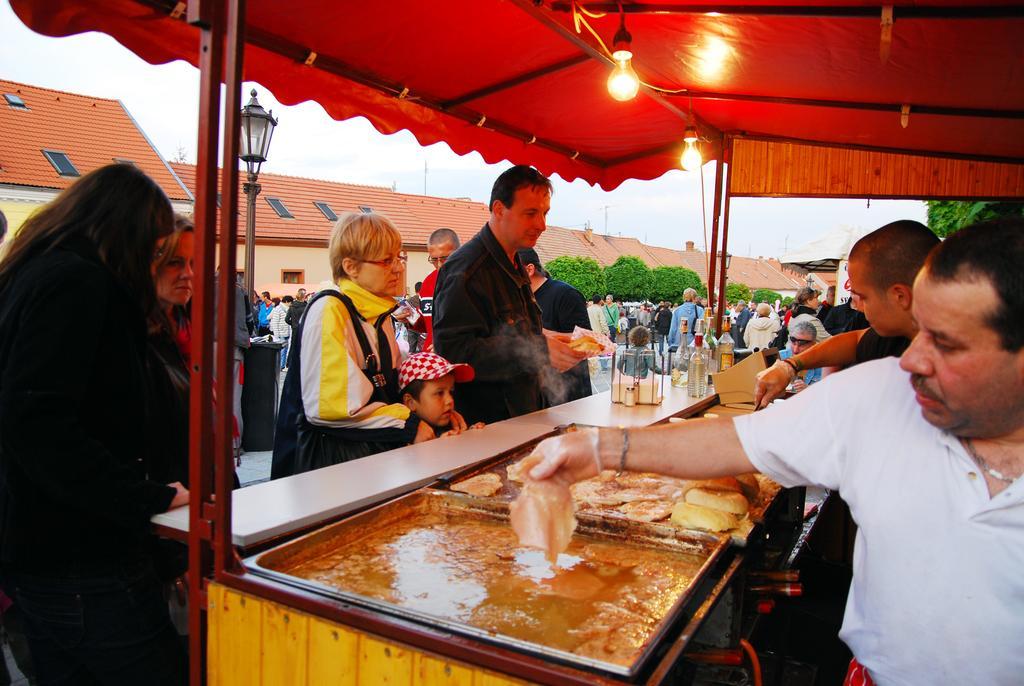Could you give a brief overview of what you see in this image? This image consists of many people. In the middle, we can see the stoves. On the right, the two men are cooking. At the top, we can see a tent along with a light. In the background, there are trees and buildings. 